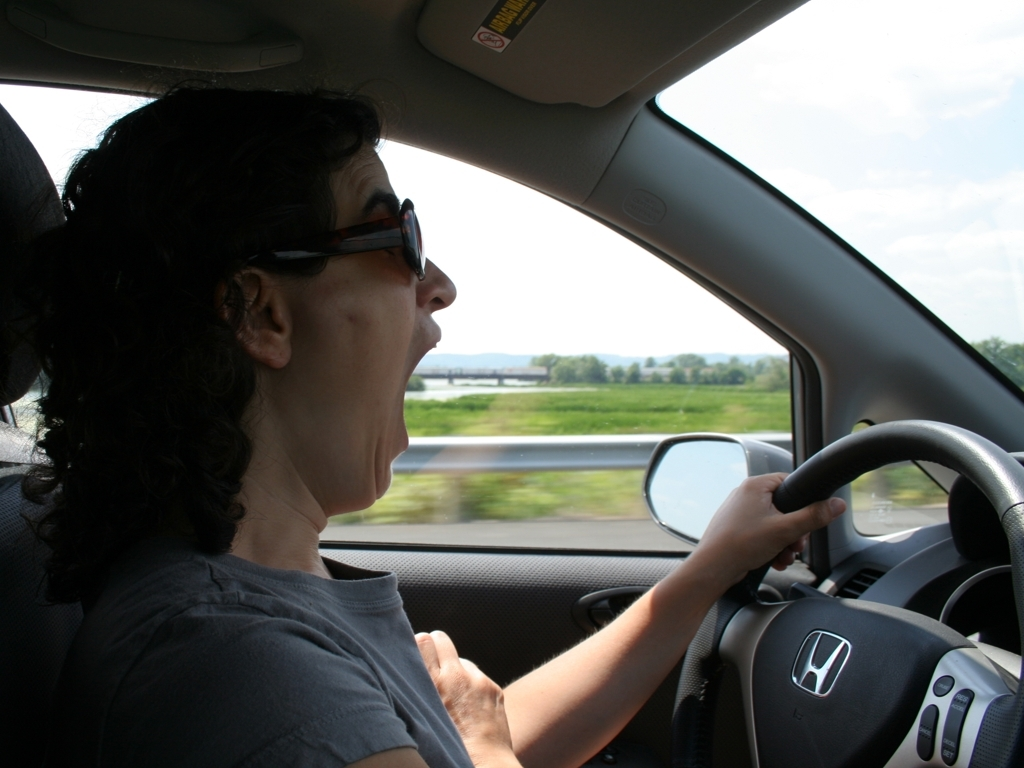Are there any quality issues with this image? Yes, there are several quality issues with the image. The main issues include motion blur, likely due to the vehicle's movement, and overexposure on the window side, causing a lack of detail in that area. Additionally, the framing cuts out part of the driver's arm, and the image appears slightly tilted, which affects the overall composition. 